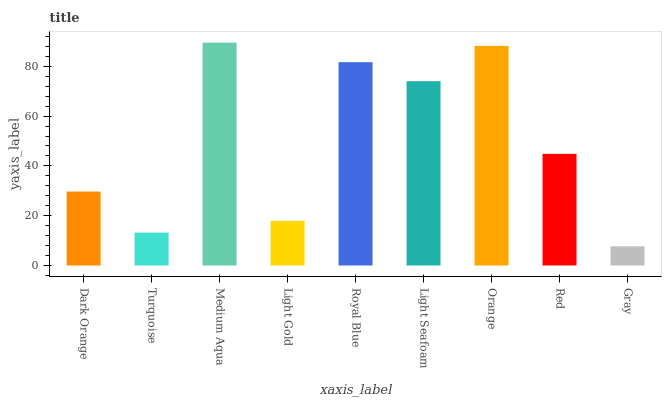Is Turquoise the minimum?
Answer yes or no. No. Is Turquoise the maximum?
Answer yes or no. No. Is Dark Orange greater than Turquoise?
Answer yes or no. Yes. Is Turquoise less than Dark Orange?
Answer yes or no. Yes. Is Turquoise greater than Dark Orange?
Answer yes or no. No. Is Dark Orange less than Turquoise?
Answer yes or no. No. Is Red the high median?
Answer yes or no. Yes. Is Red the low median?
Answer yes or no. Yes. Is Light Seafoam the high median?
Answer yes or no. No. Is Light Seafoam the low median?
Answer yes or no. No. 